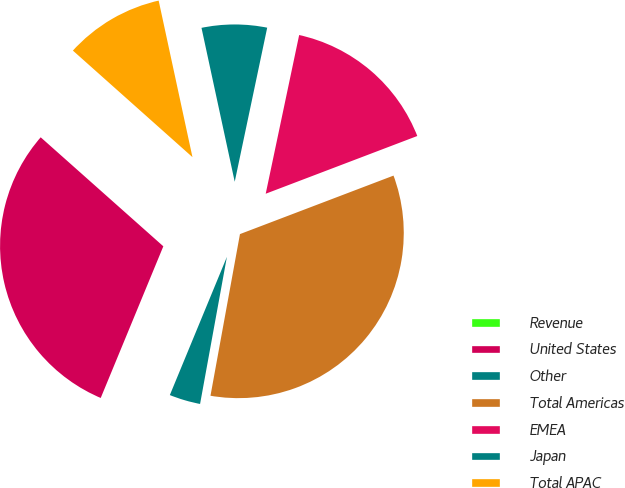Convert chart to OTSL. <chart><loc_0><loc_0><loc_500><loc_500><pie_chart><fcel>Revenue<fcel>United States<fcel>Other<fcel>Total Americas<fcel>EMEA<fcel>Japan<fcel>Total APAC<nl><fcel>0.02%<fcel>30.33%<fcel>3.36%<fcel>33.66%<fcel>15.9%<fcel>6.69%<fcel>10.03%<nl></chart> 